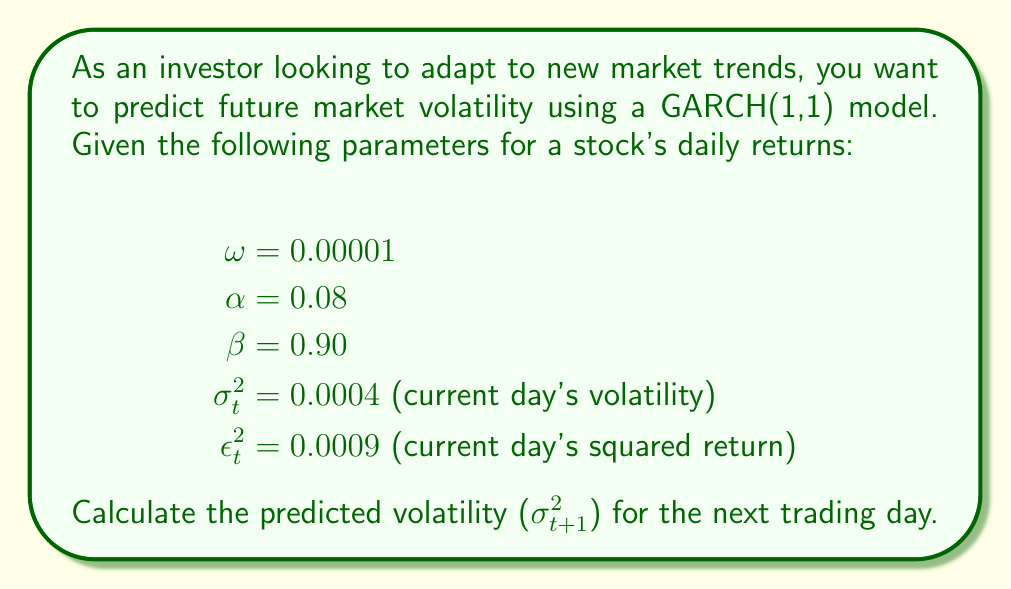Show me your answer to this math problem. To predict the volatility for the next trading day using a GARCH(1,1) model, we follow these steps:

1. Recall the GARCH(1,1) model equation:
   $$\sigma_{t+1}^2 = \omega + \alpha \epsilon_t^2 + \beta \sigma_t^2$$

2. Substitute the given parameters into the equation:
   $$\sigma_{t+1}^2 = 0.00001 + 0.08 \times 0.0009 + 0.90 \times 0.0004$$

3. Calculate each term:
   - $\omega = 0.00001$
   - $\alpha \epsilon_t^2 = 0.08 \times 0.0009 = 0.000072$
   - $\beta \sigma_t^2 = 0.90 \times 0.0004 = 0.00036$

4. Sum up all terms:
   $$\sigma_{t+1}^2 = 0.00001 + 0.000072 + 0.00036 = 0.000442$$

5. The predicted volatility for the next trading day is 0.000442.
Answer: 0.000442 